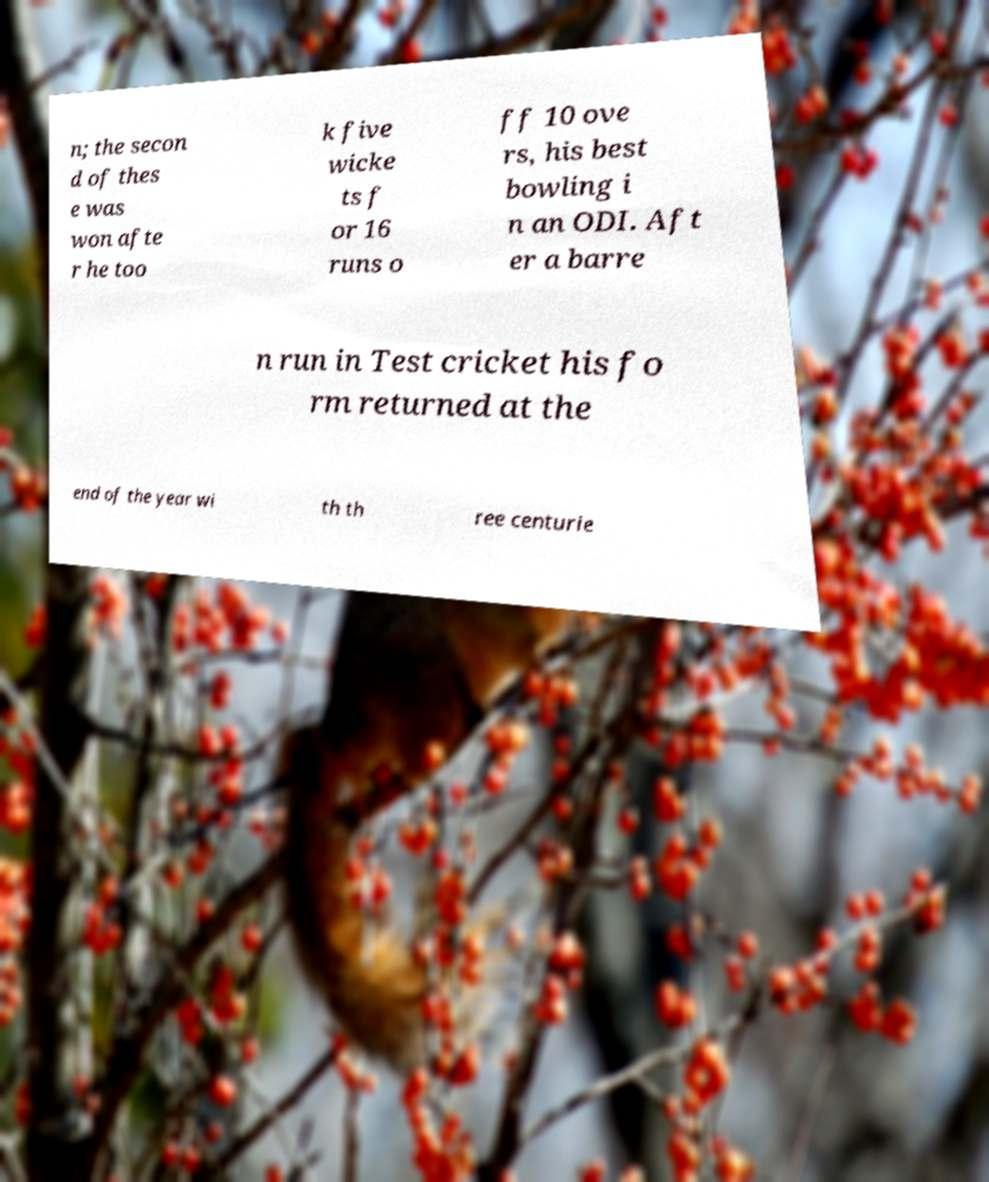Could you assist in decoding the text presented in this image and type it out clearly? n; the secon d of thes e was won afte r he too k five wicke ts f or 16 runs o ff 10 ove rs, his best bowling i n an ODI. Aft er a barre n run in Test cricket his fo rm returned at the end of the year wi th th ree centurie 